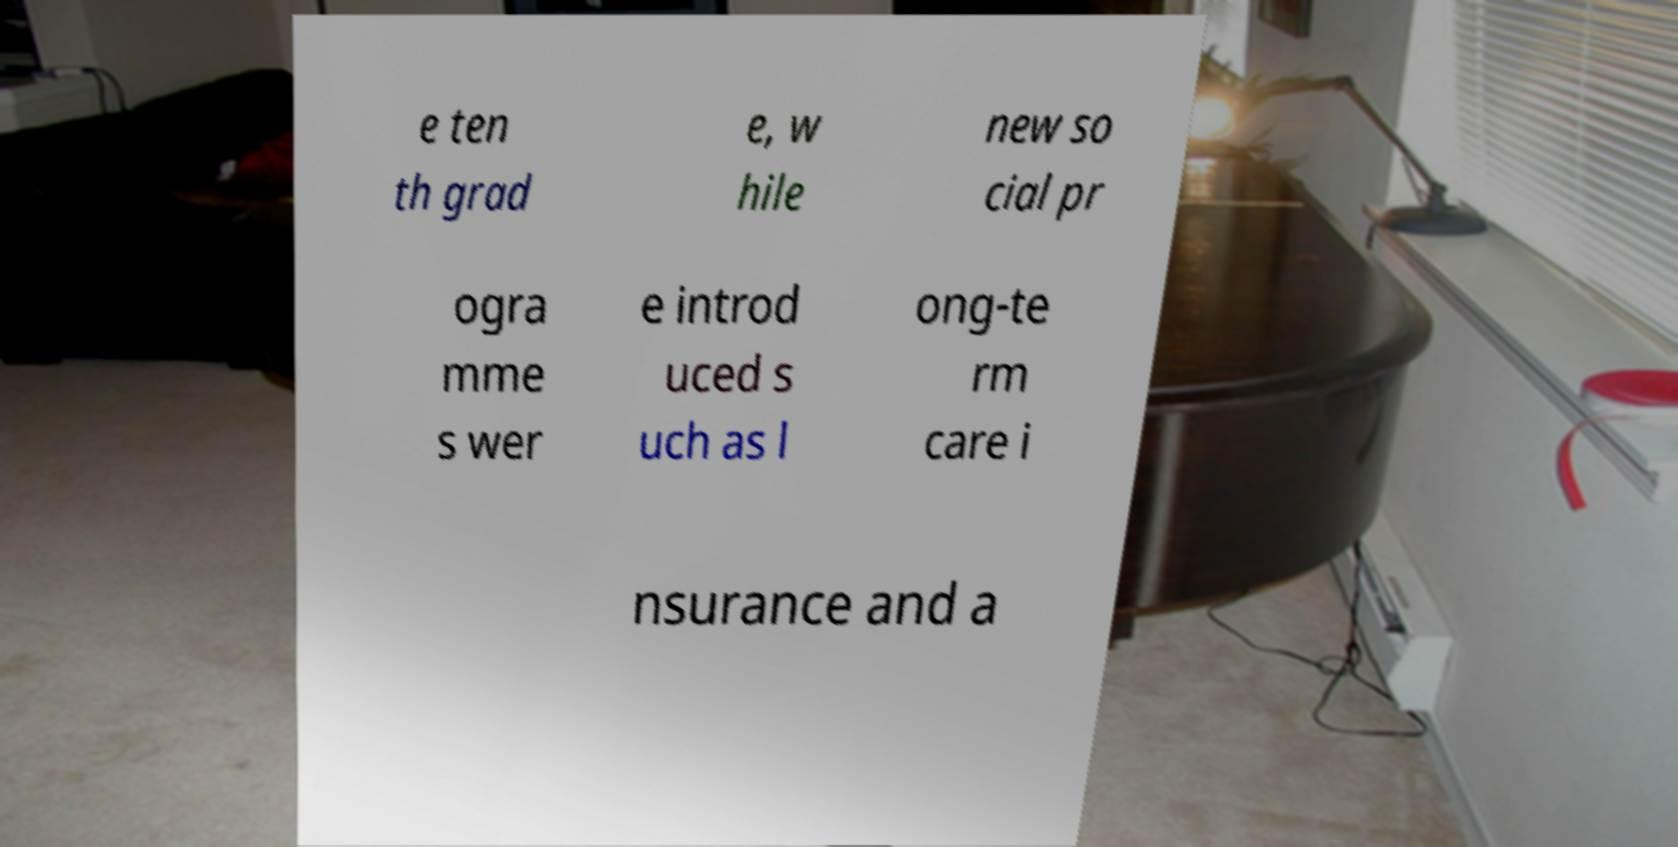Please identify and transcribe the text found in this image. e ten th grad e, w hile new so cial pr ogra mme s wer e introd uced s uch as l ong-te rm care i nsurance and a 